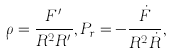<formula> <loc_0><loc_0><loc_500><loc_500>\rho = \frac { F ^ { \prime } } { R ^ { 2 } R ^ { \prime } } , P _ { r } = - \frac { \dot { F } } { R ^ { 2 } \dot { R } } ,</formula> 